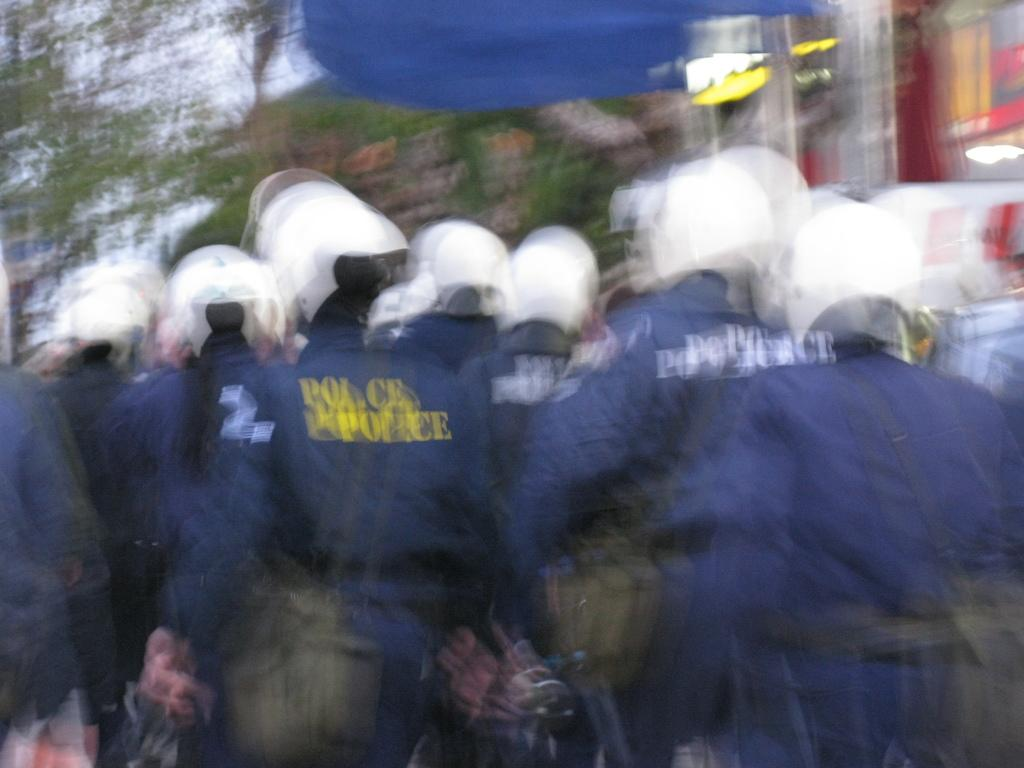What is the main structure visible in the image? There is a building in the image. What is happening in front of the building? There is a group of people standing in front of the building. Can you describe the quality of the image? The image is slightly blurred. What type of string is being used to limit the movement of the building in the image? There is no string or any indication of limiting the movement of the building in the image. 